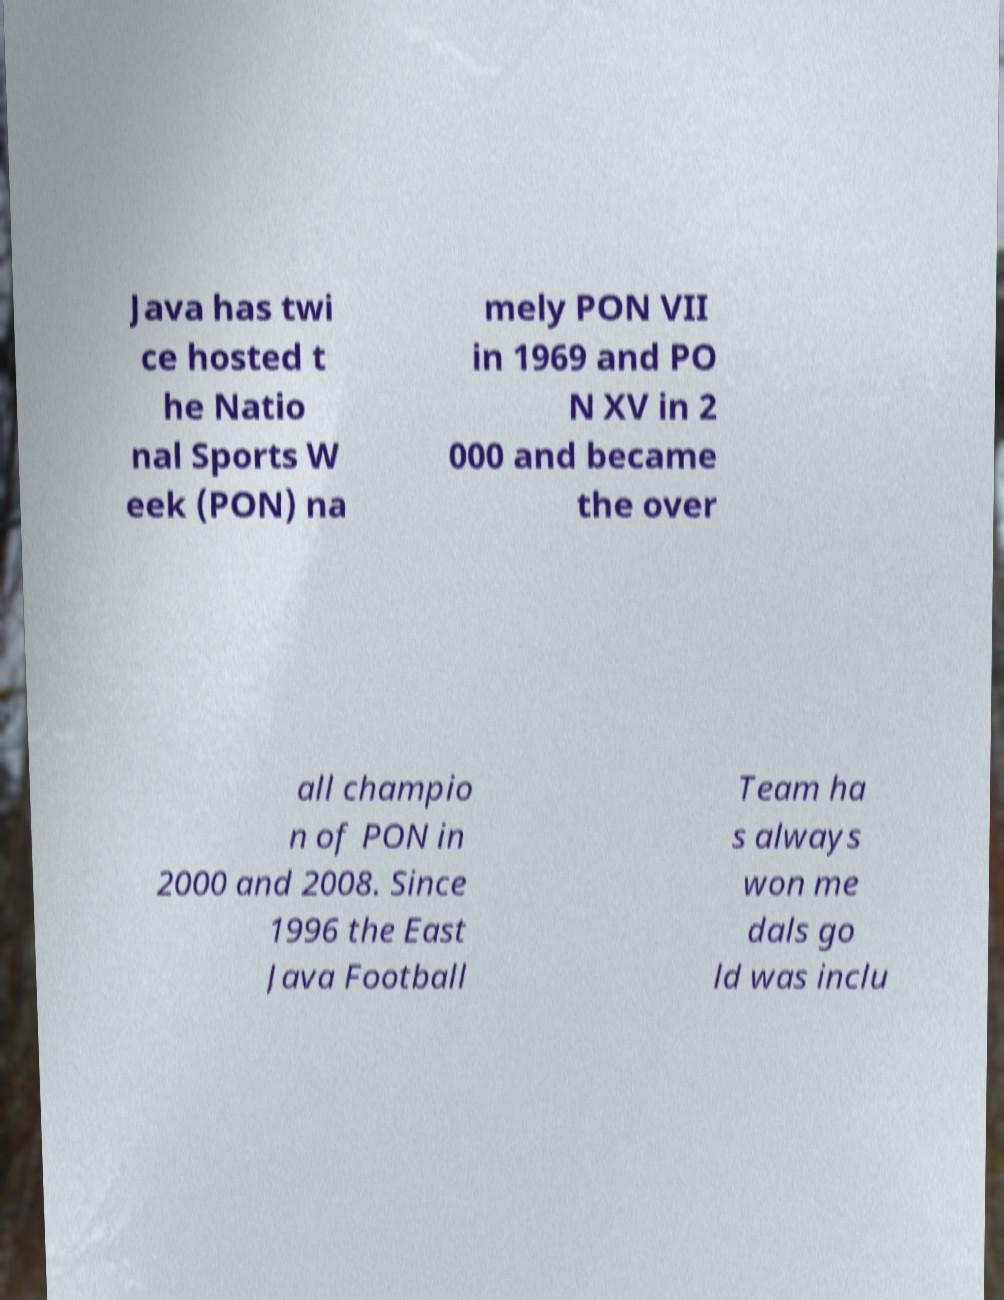Could you assist in decoding the text presented in this image and type it out clearly? Java has twi ce hosted t he Natio nal Sports W eek (PON) na mely PON VII in 1969 and PO N XV in 2 000 and became the over all champio n of PON in 2000 and 2008. Since 1996 the East Java Football Team ha s always won me dals go ld was inclu 